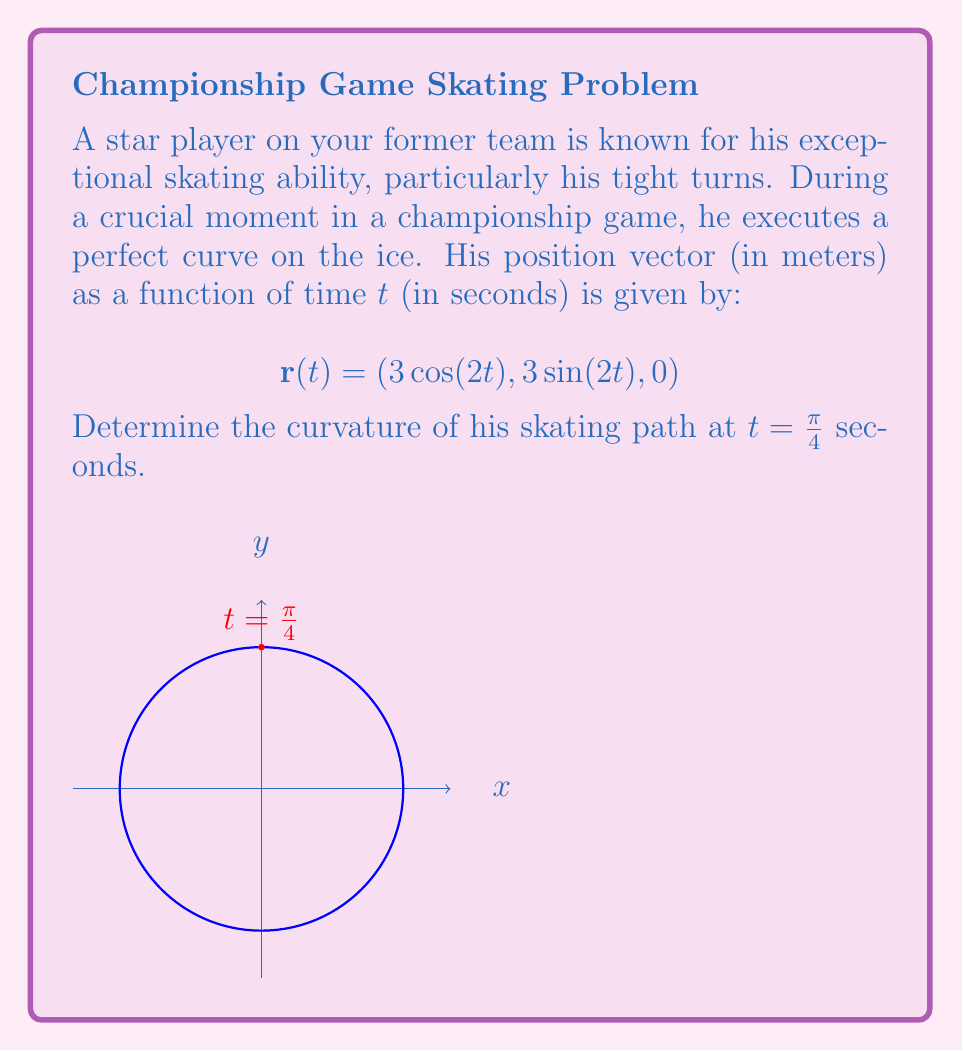Solve this math problem. To find the curvature, we'll use the formula:

$$\kappa = \frac{|\mathbf{r}'(t) \times \mathbf{r}''(t)|}{|\mathbf{r}'(t)|^3}$$

Step 1: Calculate $\mathbf{r}'(t)$
$$\mathbf{r}'(t) = (-6\sin(2t), 6\cos(2t), 0)$$

Step 2: Calculate $\mathbf{r}''(t)$
$$\mathbf{r}''(t) = (-12\cos(2t), -12\sin(2t), 0)$$

Step 3: Calculate $\mathbf{r}'(t) \times \mathbf{r}''(t)$
$$\mathbf{r}'(t) \times \mathbf{r}''(t) = (0, 0, -72\sin^2(2t) - 72\cos^2(2t)) = (0, 0, -72)$$

Step 4: Calculate $|\mathbf{r}'(t) \times \mathbf{r}''(t)|$
$$|\mathbf{r}'(t) \times \mathbf{r}''(t)| = 72$$

Step 5: Calculate $|\mathbf{r}'(t)|$
$$|\mathbf{r}'(t)| = \sqrt{36\sin^2(2t) + 36\cos^2(2t)} = 6$$

Step 6: Apply the curvature formula at t = π/4
$$\kappa = \frac{72}{6^3} = \frac{1}{3}$$

The curvature is constant for all t, including t = π/4, because this path describes a circle with radius 3.
Answer: $\frac{1}{3}$ m$^{-1}$ 